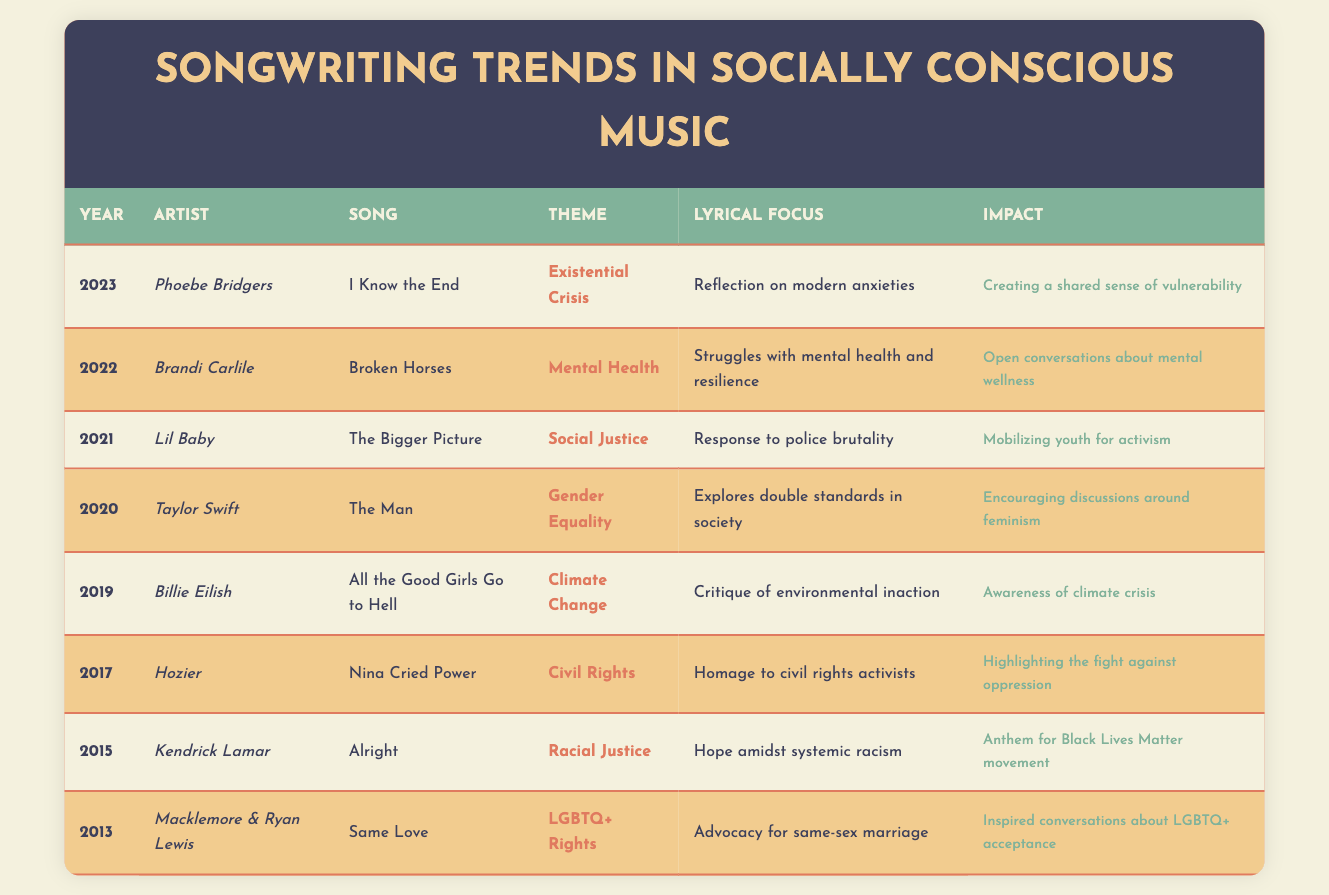What year did Phoebe Bridgers release "I Know the End"? The table lists the release year for each song. Looking at the row for Phoebe Bridgers and her song "I Know the End," the year is specifically mentioned as 2023.
Answer: 2023 Which song by Taylor Swift focuses on gender equality? To find the correct song, I check the row related to Taylor Swift in the table. The song listed in the row for her is "The Man," which is specifically identified as focusing on gender equality.
Answer: The Man How many songs address themes related to mental health in the dataset? By examining the table, I can see that Brandi Carlile's song "Broken Horses" is the only one that explicitly addresses mental health. Therefore, I count just one song in this category.
Answer: 1 Did Kendrick Lamar's song serve as an anthem for the Black Lives Matter movement? The table states that Kendrick Lamar's song "Alright" has an impact described as "Anthem for Black Lives Matter movement," which confirms that the statement is true.
Answer: Yes In which year did songs about Climate Change and Gender Equality appear? The table indicates that Billie Eilish's song about climate change was released in 2019, while Taylor Swift's song focused on gender equality was released in 2020. Therefore, the years of interest are 2019 and 2020.
Answer: 2019 and 2020 Which artist released a song that references existential crises among modern anxieties? By reviewing the table, I locate Phoebe Bridgers's song "I Know the End," which focuses on existential crisis. Thus, the artist connected with existential themes is Phoebe Bridgers.
Answer: Phoebe Bridgers What is the lyrical focus of Hozier's "Nina Cried Power"? To answer this, I check the relevant row for Hozier's song "Nina Cried Power." The lyrical focus is described as "Homage to civil rights activists," which directly answers the question.
Answer: Homage to civil rights activists List the themes addressed by songs released between 2015 and 2022. By scanning through each relevant row from 2015 to 2022 in the table, I can compile the following themes: Racial Justice (2015), Civil Rights (2017), Climate Change (2019), Gender Equality (2020), Social Justice (2021), and Mental Health (2022). This provides a total of six distinct themes.
Answer: Racial Justice, Civil Rights, Climate Change, Gender Equality, Social Justice, Mental Health Which song has the strongest impact according to the table? To evaluate the impact, I review each impact statement provided in the table. Since "The Bigger Picture" by Lil Baby is noted for "Mobilizing youth for activism" and feels very impactful in a social context, it might be regarded as having the strongest impact. However, this is subjective based on interpretation, so "Alright" is also considered significant for the Black Lives Matter movement.
Answer: It can be subjective; notable mentions include "The Bigger Picture" and "Alright" 